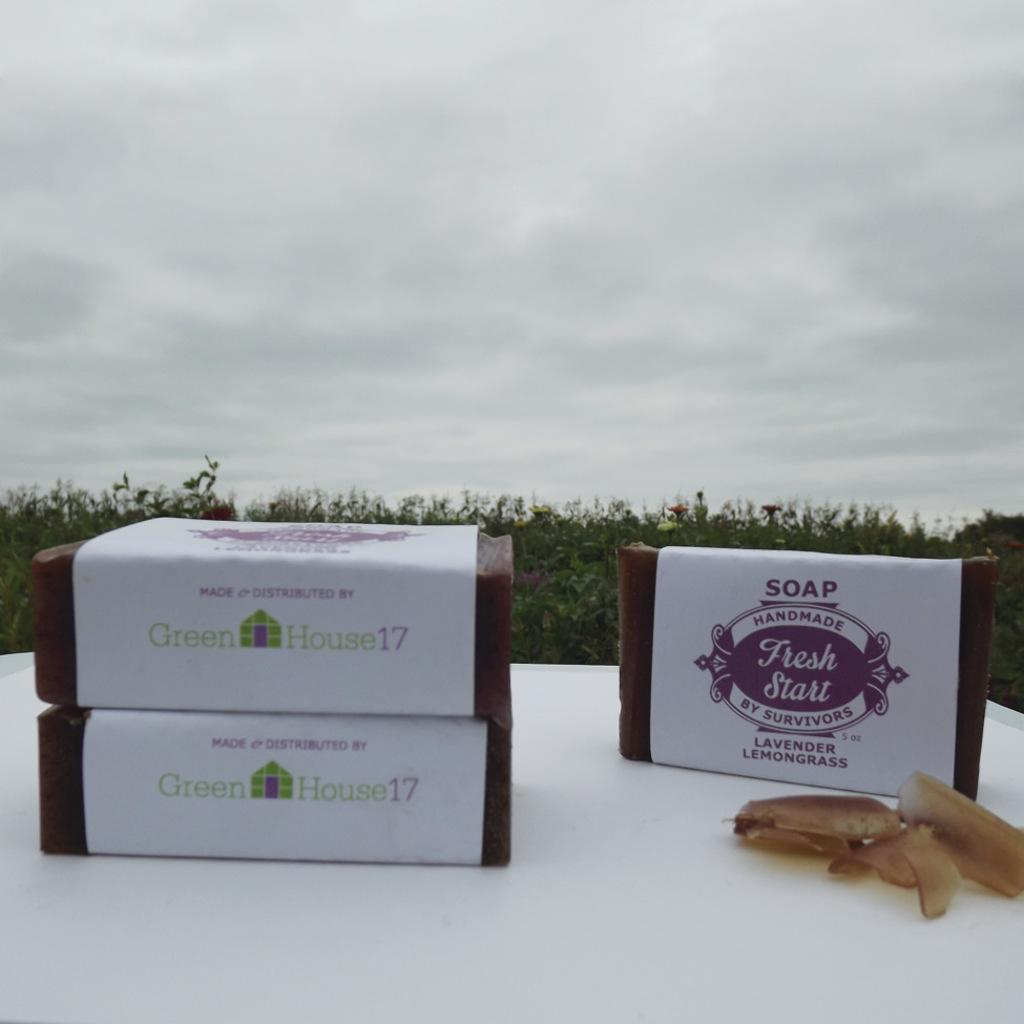How many blocks are in the image? There are three brown color blocks in the image. What color are the blocks? The blocks are brown. Where are the blocks placed? The blocks are placed on a white color table. What can be seen in the background of the image? There are plants and the sky visible in the background of the image. What type of representative is looking at the blocks in the image? There is no representative or person looking at the blocks in the image. Can you tell me how many pails are present in the image? There are no pails present in the image. 